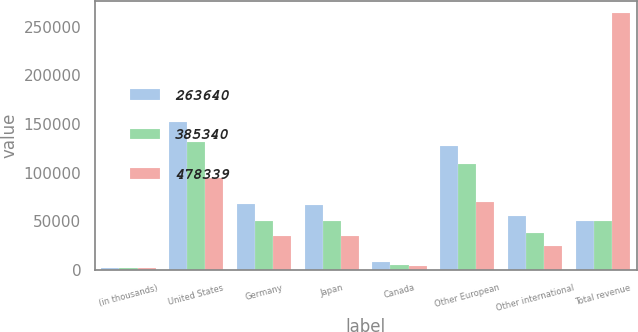<chart> <loc_0><loc_0><loc_500><loc_500><stacked_bar_chart><ecel><fcel>(in thousands)<fcel>United States<fcel>Germany<fcel>Japan<fcel>Canada<fcel>Other European<fcel>Other international<fcel>Total revenue<nl><fcel>263640<fcel>2008<fcel>151688<fcel>68390<fcel>66960<fcel>8033<fcel>127246<fcel>56022<fcel>50934.5<nl><fcel>385340<fcel>2007<fcel>131777<fcel>50973<fcel>50896<fcel>4809<fcel>108971<fcel>37914<fcel>50934.5<nl><fcel>478339<fcel>2006<fcel>94282<fcel>34567<fcel>35391<fcel>4255<fcel>70184<fcel>24961<fcel>263640<nl></chart> 